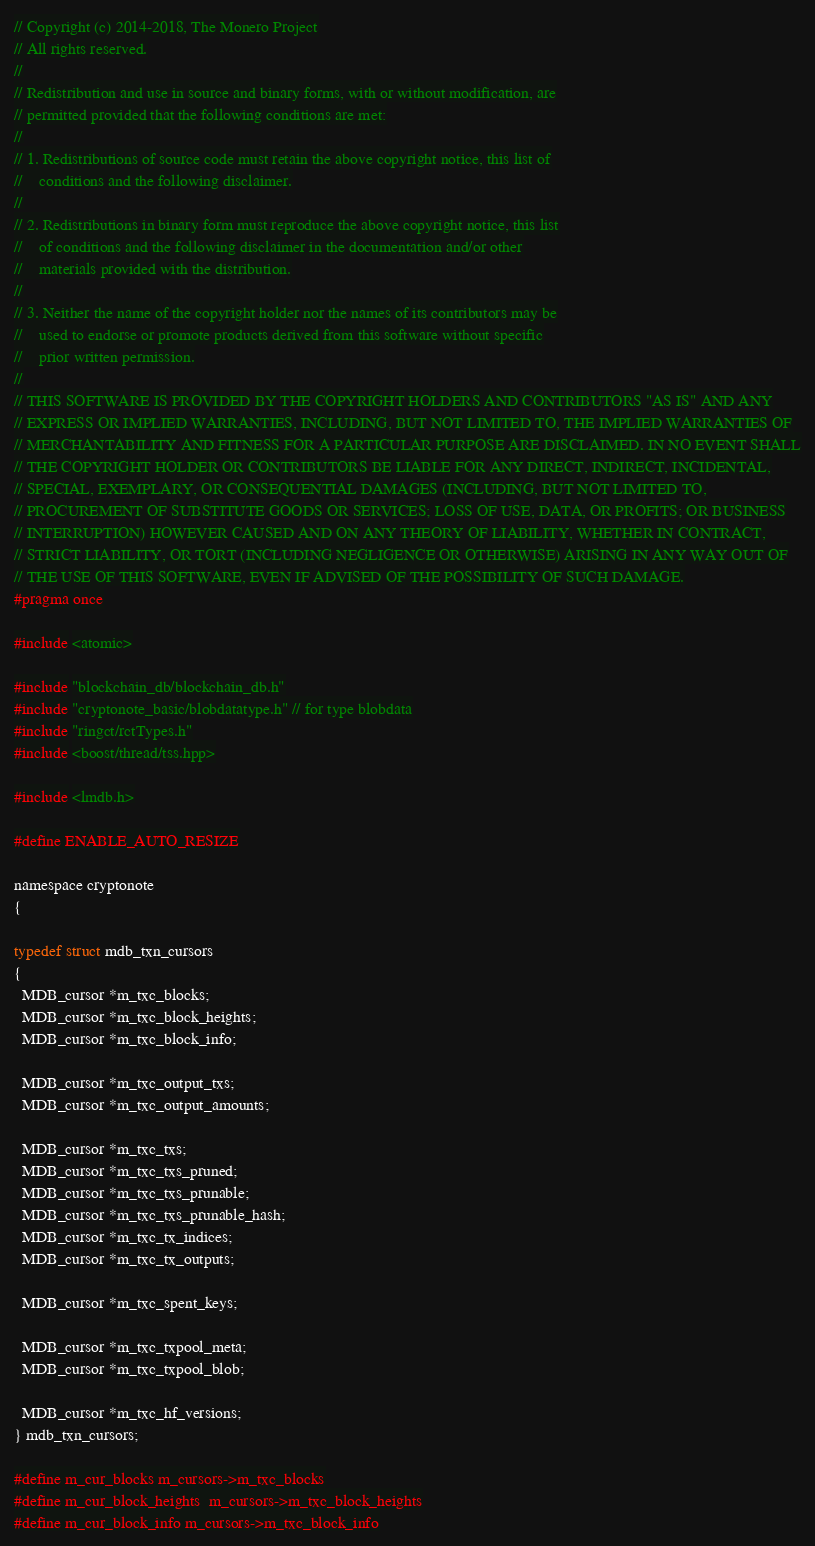Convert code to text. <code><loc_0><loc_0><loc_500><loc_500><_C_>// Copyright (c) 2014-2018, The Monero Project
// All rights reserved.
//
// Redistribution and use in source and binary forms, with or without modification, are
// permitted provided that the following conditions are met:
//
// 1. Redistributions of source code must retain the above copyright notice, this list of
//    conditions and the following disclaimer.
//
// 2. Redistributions in binary form must reproduce the above copyright notice, this list
//    of conditions and the following disclaimer in the documentation and/or other
//    materials provided with the distribution.
//
// 3. Neither the name of the copyright holder nor the names of its contributors may be
//    used to endorse or promote products derived from this software without specific
//    prior written permission.
//
// THIS SOFTWARE IS PROVIDED BY THE COPYRIGHT HOLDERS AND CONTRIBUTORS "AS IS" AND ANY
// EXPRESS OR IMPLIED WARRANTIES, INCLUDING, BUT NOT LIMITED TO, THE IMPLIED WARRANTIES OF
// MERCHANTABILITY AND FITNESS FOR A PARTICULAR PURPOSE ARE DISCLAIMED. IN NO EVENT SHALL
// THE COPYRIGHT HOLDER OR CONTRIBUTORS BE LIABLE FOR ANY DIRECT, INDIRECT, INCIDENTAL,
// SPECIAL, EXEMPLARY, OR CONSEQUENTIAL DAMAGES (INCLUDING, BUT NOT LIMITED TO,
// PROCUREMENT OF SUBSTITUTE GOODS OR SERVICES; LOSS OF USE, DATA, OR PROFITS; OR BUSINESS
// INTERRUPTION) HOWEVER CAUSED AND ON ANY THEORY OF LIABILITY, WHETHER IN CONTRACT,
// STRICT LIABILITY, OR TORT (INCLUDING NEGLIGENCE OR OTHERWISE) ARISING IN ANY WAY OUT OF
// THE USE OF THIS SOFTWARE, EVEN IF ADVISED OF THE POSSIBILITY OF SUCH DAMAGE.
#pragma once

#include <atomic>

#include "blockchain_db/blockchain_db.h"
#include "cryptonote_basic/blobdatatype.h" // for type blobdata
#include "ringct/rctTypes.h"
#include <boost/thread/tss.hpp>

#include <lmdb.h>

#define ENABLE_AUTO_RESIZE

namespace cryptonote
{

typedef struct mdb_txn_cursors
{
  MDB_cursor *m_txc_blocks;
  MDB_cursor *m_txc_block_heights;
  MDB_cursor *m_txc_block_info;

  MDB_cursor *m_txc_output_txs;
  MDB_cursor *m_txc_output_amounts;

  MDB_cursor *m_txc_txs;
  MDB_cursor *m_txc_txs_pruned;
  MDB_cursor *m_txc_txs_prunable;
  MDB_cursor *m_txc_txs_prunable_hash;
  MDB_cursor *m_txc_tx_indices;
  MDB_cursor *m_txc_tx_outputs;

  MDB_cursor *m_txc_spent_keys;

  MDB_cursor *m_txc_txpool_meta;
  MDB_cursor *m_txc_txpool_blob;

  MDB_cursor *m_txc_hf_versions;
} mdb_txn_cursors;

#define m_cur_blocks	m_cursors->m_txc_blocks
#define m_cur_block_heights	m_cursors->m_txc_block_heights
#define m_cur_block_info	m_cursors->m_txc_block_info</code> 